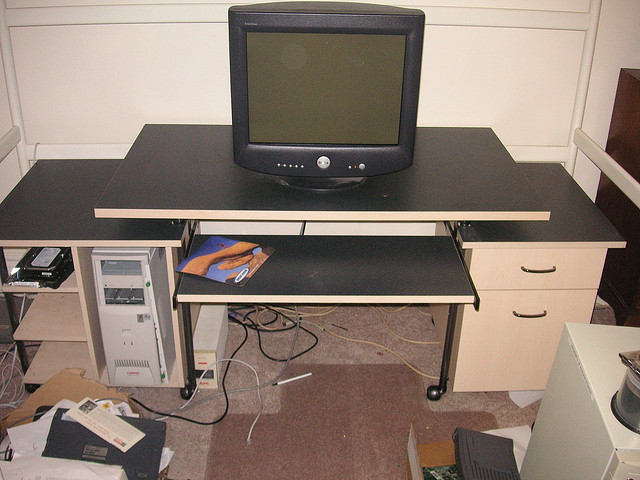How many people are lying down underneath the truck? 0 